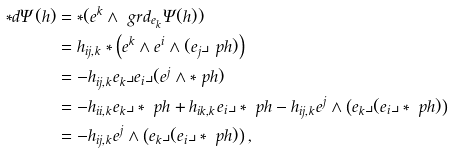<formula> <loc_0><loc_0><loc_500><loc_500>* d \Psi ( h ) & = * ( e ^ { k } \wedge \ g r d _ { e _ { k } } \Psi ( h ) ) \\ & = h _ { i j , k } * \left ( e ^ { k } \wedge e ^ { i } \wedge ( e _ { j } \lrcorner \ p h ) \right ) \\ & = - h _ { i j , k } e _ { k } \lrcorner e _ { i } \lrcorner ( e ^ { j } \wedge * \ p h ) \\ & = - h _ { i i , k } e _ { k } \lrcorner * \ p h + h _ { i k , k } e _ { i } \lrcorner * \ p h - h _ { i j , k } e ^ { j } \wedge \left ( e _ { k } \lrcorner ( e _ { i } \lrcorner * \ p h ) \right ) \\ & = - h _ { i j , k } e ^ { j } \wedge \left ( e _ { k } \lrcorner ( e _ { i } \lrcorner * \ p h ) \right ) ,</formula> 